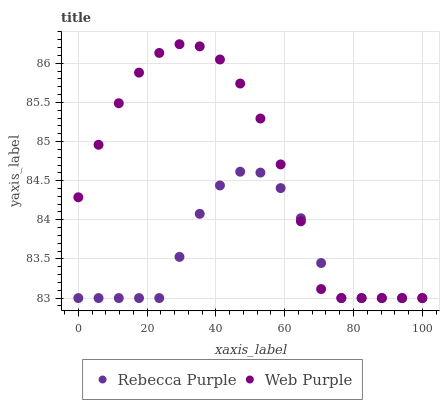Does Rebecca Purple have the minimum area under the curve?
Answer yes or no. Yes. Does Web Purple have the maximum area under the curve?
Answer yes or no. Yes. Does Rebecca Purple have the maximum area under the curve?
Answer yes or no. No. Is Rebecca Purple the smoothest?
Answer yes or no. Yes. Is Web Purple the roughest?
Answer yes or no. Yes. Is Rebecca Purple the roughest?
Answer yes or no. No. Does Web Purple have the lowest value?
Answer yes or no. Yes. Does Web Purple have the highest value?
Answer yes or no. Yes. Does Rebecca Purple have the highest value?
Answer yes or no. No. Does Rebecca Purple intersect Web Purple?
Answer yes or no. Yes. Is Rebecca Purple less than Web Purple?
Answer yes or no. No. Is Rebecca Purple greater than Web Purple?
Answer yes or no. No. 